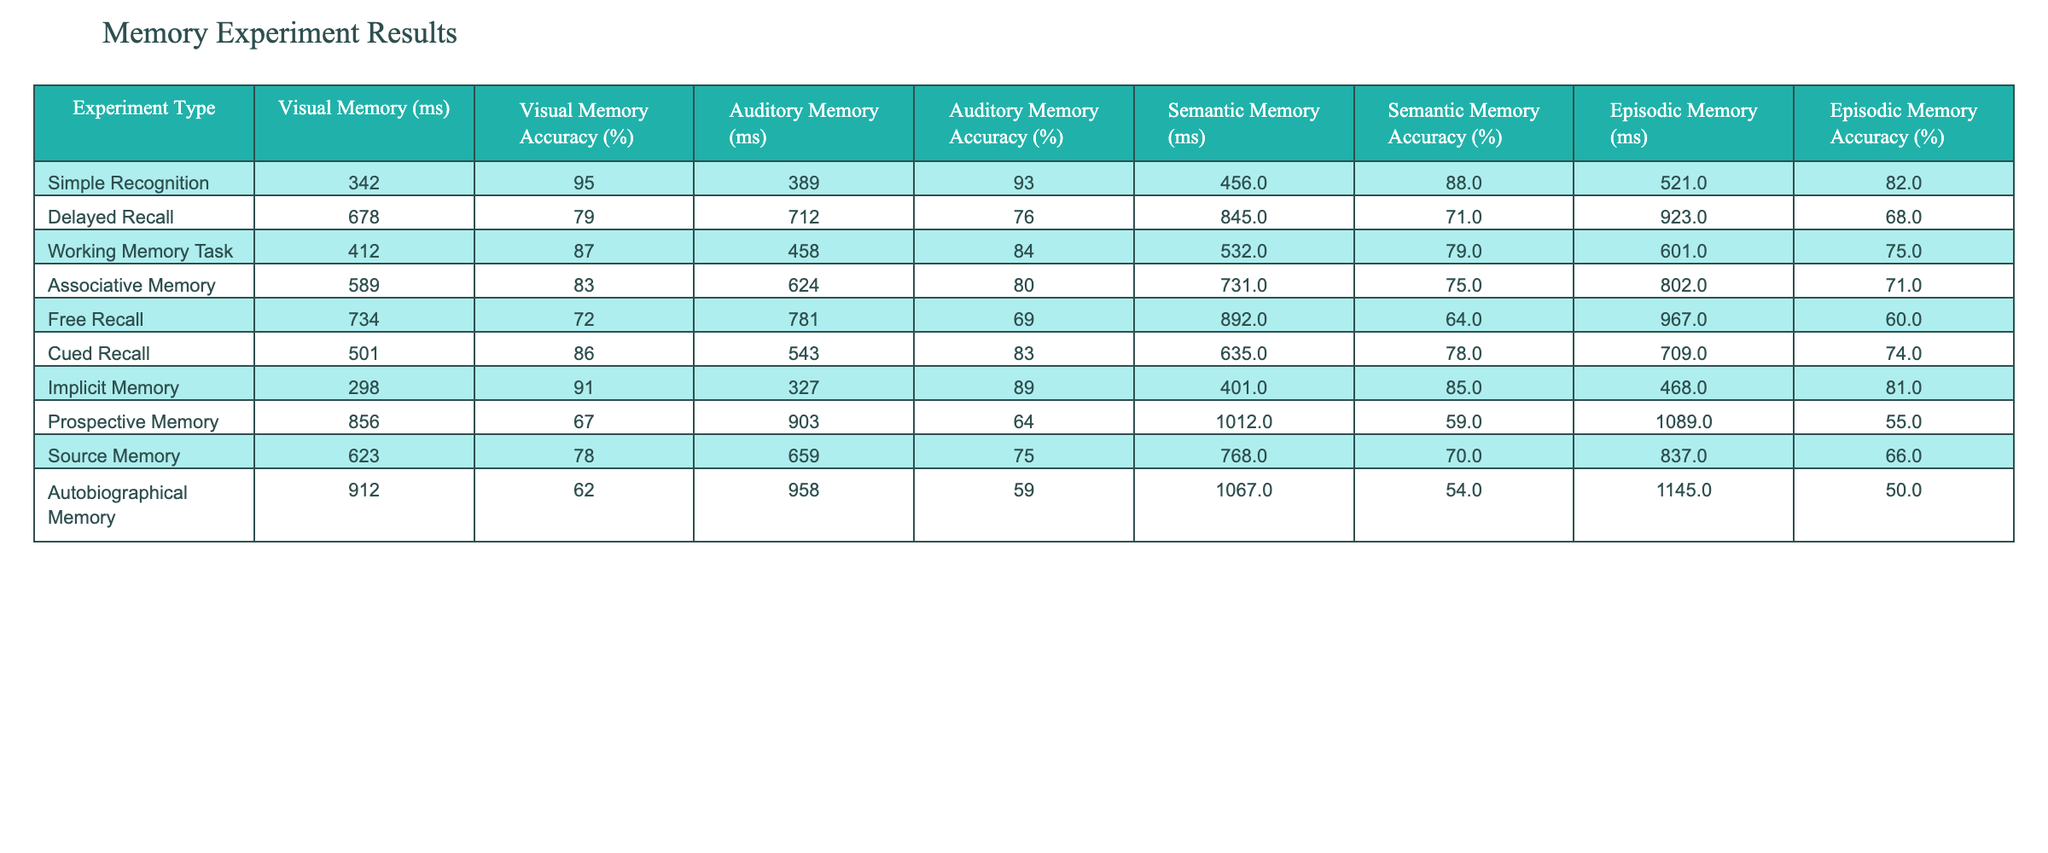What is the reaction time for the Simple Recognition experiment? The reaction time for the Simple Recognition experiment is listed in the table under the "Visual Memory (ms)" column. This value is 342 ms.
Answer: 342 ms Which type of memory recall has the highest accuracy rate? To find the highest accuracy rate, we compare the accuracy percentages across all types of memory recall. The "Visual Memory Accuracy (%)" for Simple Recognition is 95%, which is the highest.
Answer: Simple Recognition What is the difference in reaction times between Free Recall and Cued Recall experiments? The reaction time for Free Recall is 734 ms and for Cued Recall, it is 501 ms. The difference is calculated as 734 ms - 501 ms = 233 ms.
Answer: 233 ms What is the average accuracy rate for Auditory Memory experiments? The accuracy rates for Auditory Memory are 93%, 76%, 84%, 80%, 69%, 83%, 89%, 64%, 75%, and 59%. Adding these gives 93 + 76 + 84 + 80 + 69 + 83 + 89 + 64 + 75 + 59 =  63 + 155 = 825%. Dividing by the number of tests (10) gives 825 / 10 = 82.5%.
Answer: 82.5% Is the reaction time for Semantic Memory in the Working Memory Task less than that in the Delayed Recall? The reaction time for Semantic Memory in Working Memory Task is 532 ms, while in Delayed Recall, it is 845 ms. Since 532 < 845, the answer is yes.
Answer: Yes What is the lowest accuracy rate recorded for any memory type in this table? By scanning the accuracy rates, the lowest recorded value is 50%, which corresponds to Autobiographical Memory.
Answer: 50% For which memory recall type is the reaction time the longest? We compare the reaction times for all types of memory recall. The longest is found under "Prospective Memory" with 1089 ms.
Answer: Prospective Memory What is the correlation between reaction time and accuracy for Visual Memory? In the table, the Visual Memory reaction times are 342 ms, 678 ms, 412 ms, 589 ms, 734 ms, 501 ms, 298 ms, 856 ms, 623 ms, and 912 ms and the corresponding accuracy percentages are 95%, 79%, 87%, 83%, 72%, 86%, 91%, 67%, 78%, and 62%. Generally, as reaction time increases, accuracy tends to decrease. Hence, there appears to be a negative correlation.
Answer: Negative correlation Which memory type demonstrated the least amount of improvement in accuracy between the working memory and delayed recall tasks? For Working Memory Task the accuracy is 79%, and for Delayed Recall, it is 71%. The difference is 79% - 71% = 8%. We must compare this with all other memory types and notice that the Least Improvement is 8%.
Answer: 8% If you were to sort the experiments by reaction time, which experiment comes third? By sorting the reaction times from lowest to highest: Implicit Memory (298 ms), Simple Recognition (342 ms), Working Memory Task (412 ms), the third experiment is Working Memory Task.
Answer: Working Memory Task 